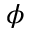<formula> <loc_0><loc_0><loc_500><loc_500>\phi</formula> 